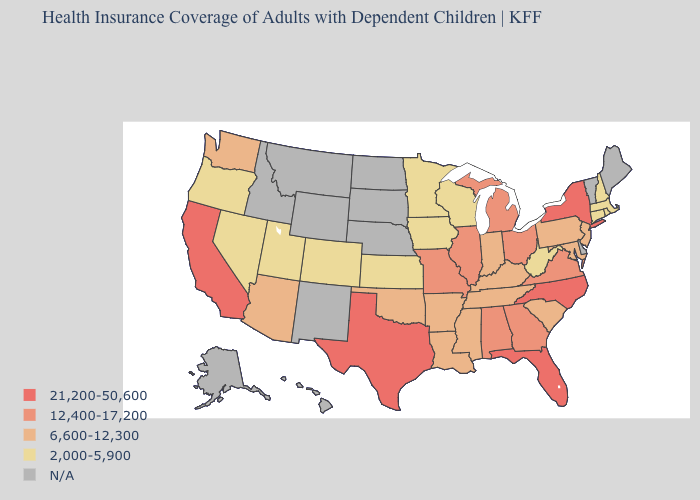Which states have the lowest value in the South?
Answer briefly. West Virginia. Which states have the highest value in the USA?
Keep it brief. California, Florida, New York, North Carolina, Texas. Among the states that border Wisconsin , which have the lowest value?
Short answer required. Iowa, Minnesota. How many symbols are there in the legend?
Be succinct. 5. What is the lowest value in states that border Colorado?
Quick response, please. 2,000-5,900. What is the value of Kentucky?
Answer briefly. 6,600-12,300. Which states have the highest value in the USA?
Write a very short answer. California, Florida, New York, North Carolina, Texas. What is the highest value in the MidWest ?
Quick response, please. 12,400-17,200. What is the lowest value in the USA?
Keep it brief. 2,000-5,900. Name the states that have a value in the range N/A?
Write a very short answer. Alaska, Delaware, Hawaii, Idaho, Maine, Montana, Nebraska, New Mexico, North Dakota, South Dakota, Vermont, Wyoming. Name the states that have a value in the range 2,000-5,900?
Answer briefly. Colorado, Connecticut, Iowa, Kansas, Massachusetts, Minnesota, Nevada, New Hampshire, Oregon, Rhode Island, Utah, West Virginia, Wisconsin. 